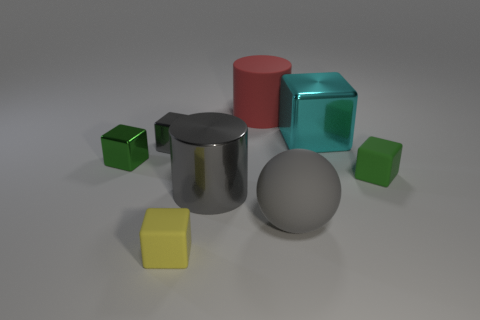What number of objects are either big gray things or tiny gray metallic objects?
Keep it short and to the point. 3. There is a cube in front of the large gray rubber ball; is its size the same as the metallic block that is in front of the small gray cube?
Ensure brevity in your answer.  Yes. What number of cylinders are large gray matte objects or large objects?
Give a very brief answer. 2. Is there a small green matte sphere?
Offer a terse response. No. Is there anything else that has the same shape as the green rubber thing?
Your response must be concise. Yes. Do the rubber cylinder and the large block have the same color?
Make the answer very short. No. What number of things are either small gray objects that are to the left of the big cyan thing or tiny red matte cylinders?
Make the answer very short. 1. How many rubber objects are behind the green object that is left of the thing that is in front of the big matte ball?
Provide a succinct answer. 1. Is there anything else that is the same size as the sphere?
Your response must be concise. Yes. There is a tiny green thing on the right side of the red cylinder behind the tiny matte block that is in front of the gray matte ball; what shape is it?
Make the answer very short. Cube. 